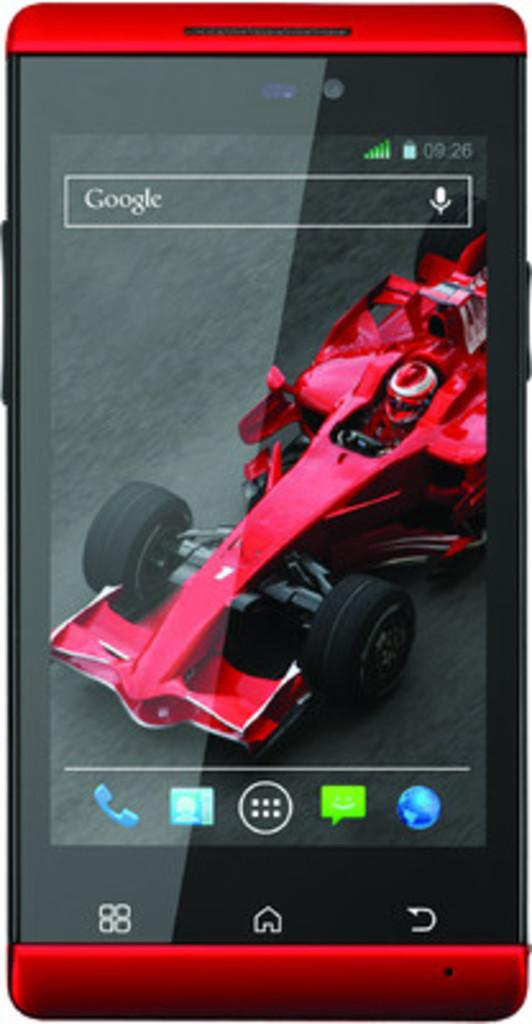What is the main subject of the image? The main subject of the image is a mobile phone screen. What can be seen on the background of the screen? The wallpaper on the screen features a car. What else is visible on the screen besides the wallpaper? There are different icons present on the screen. How many baseballs can be seen on the mobile phone screen? There are no baseballs present on the mobile phone screen; the wallpaper features a car. Can you see a kiss being exchanged on the mobile phone screen? There is no indication of a kiss being exchanged on the mobile phone screen; the image only displays the screen with a car wallpaper and various icons. 